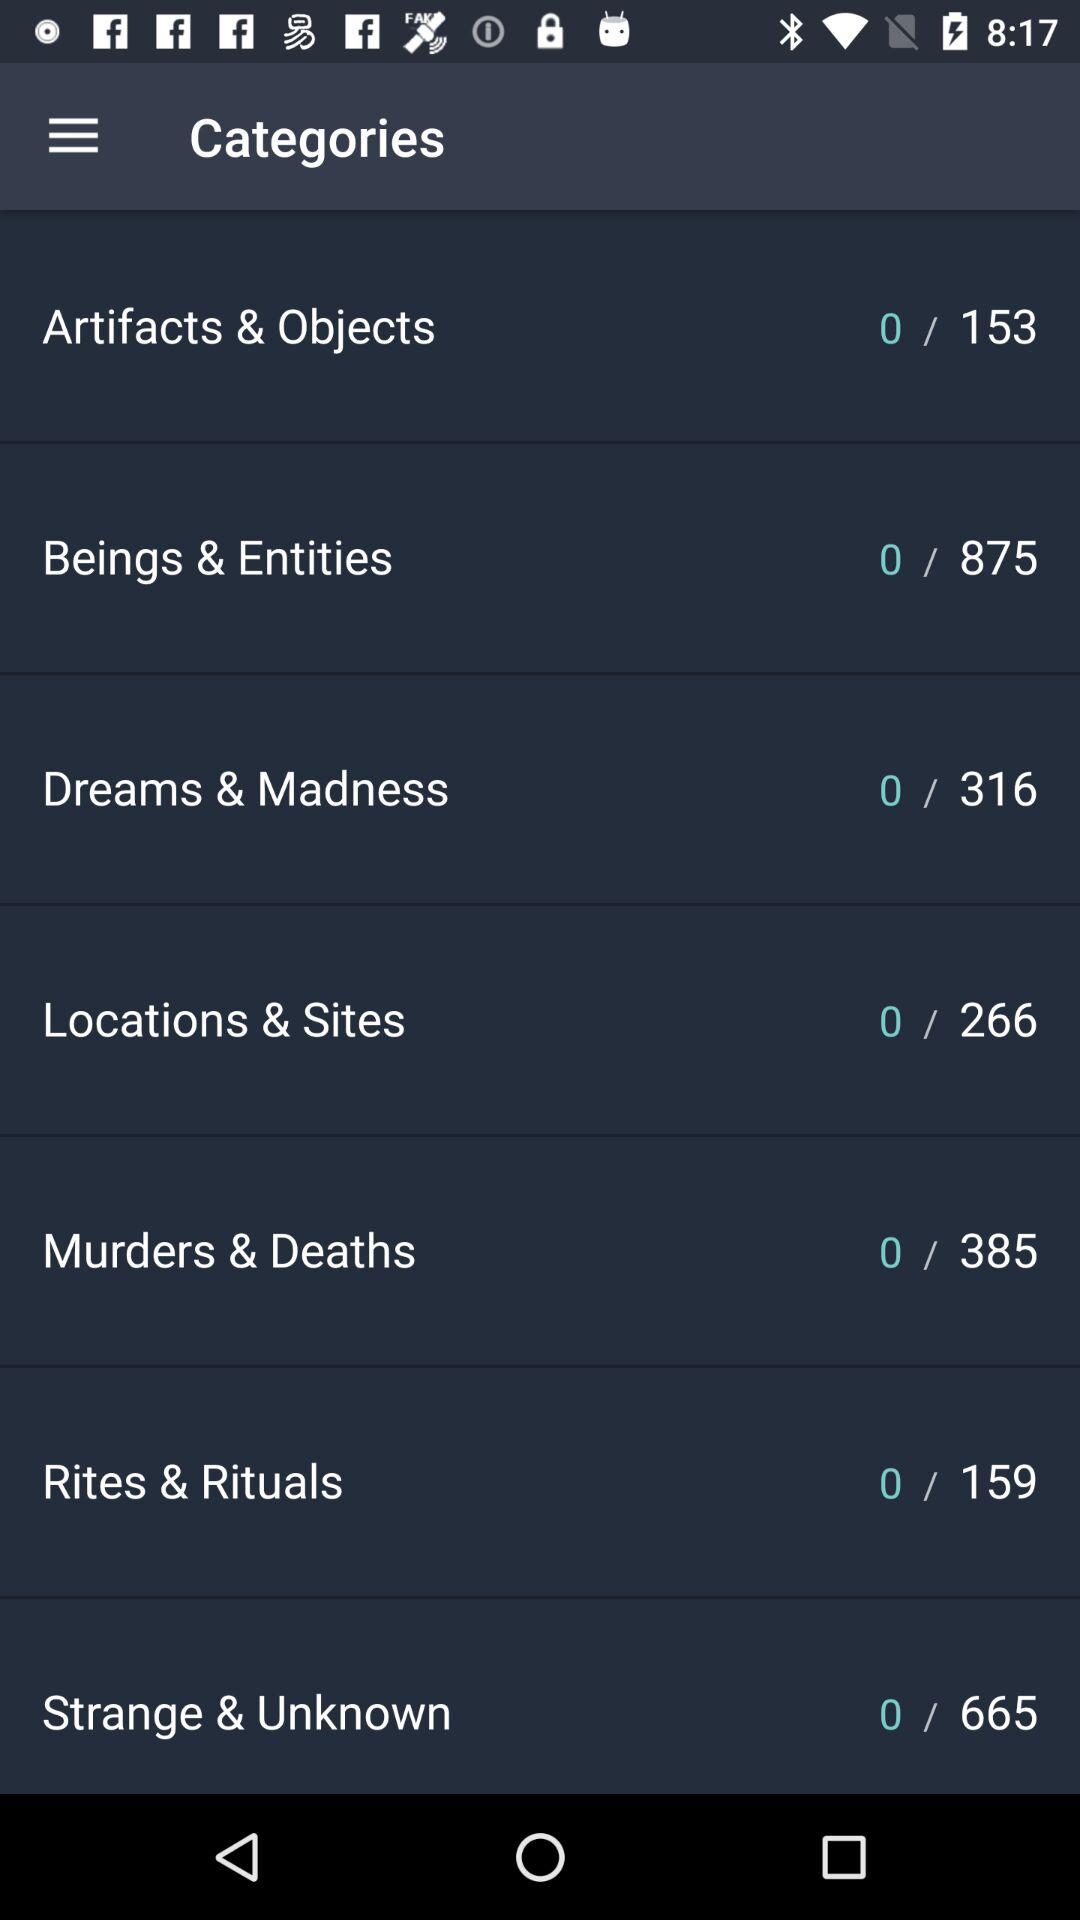What is the total number of murders and deaths? The total number of murders and deaths is 385. 